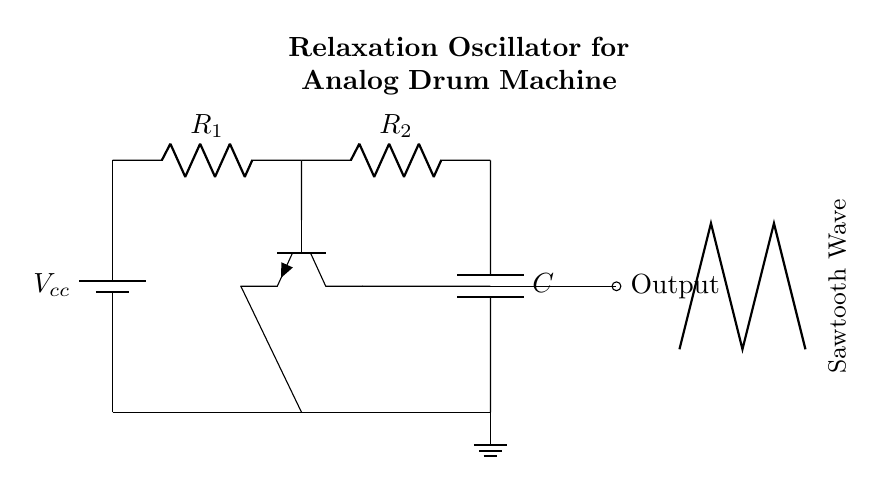What type of oscillator is shown in the circuit? The diagram shows a relaxation oscillator, which generates non-sinusoidal waveforms like sawtooth waves. This can be inferred from the title and the presence of the transistor, resistors, and capacitor, which are typical components of relaxation oscillators.
Answer: relaxation oscillator What is the function of the capacitor in this circuit? The capacitor in this circuit stores and releases energy, helping to shape the sawtooth wave. As it charges and discharges, it influences the frequency of the oscillation and the slope of the output waveform.
Answer: energy storage Which component is responsible for switching the current in the circuit? The transistor is the component that switches the current and controls the charging and discharging of the capacitor. This is evident as it connects to the base of the transistor and is part of the feedback loop necessary for oscillation.
Answer: transistor What type of output waveform does this circuit produce? The output waveform of this circuit is a sawtooth wave, which is specifically indicated in the diagram with a sketch representing the waveform. This is characteristic of relaxation oscillators like this one.
Answer: sawtooth wave How many resistors are present in the circuit? There are two resistors in this circuit, labeled as R1 and R2. This can be confirmed by counting the resistor symbols in the diagram.
Answer: two What role do the resistors play in the oscillator's function? The resistors control the charge and discharge rates of the capacitor, which directly affects the frequency and shape of the output waveform. By adjusting the resistance values, you can manipulate the oscillation speed.
Answer: charge/discharge rates 